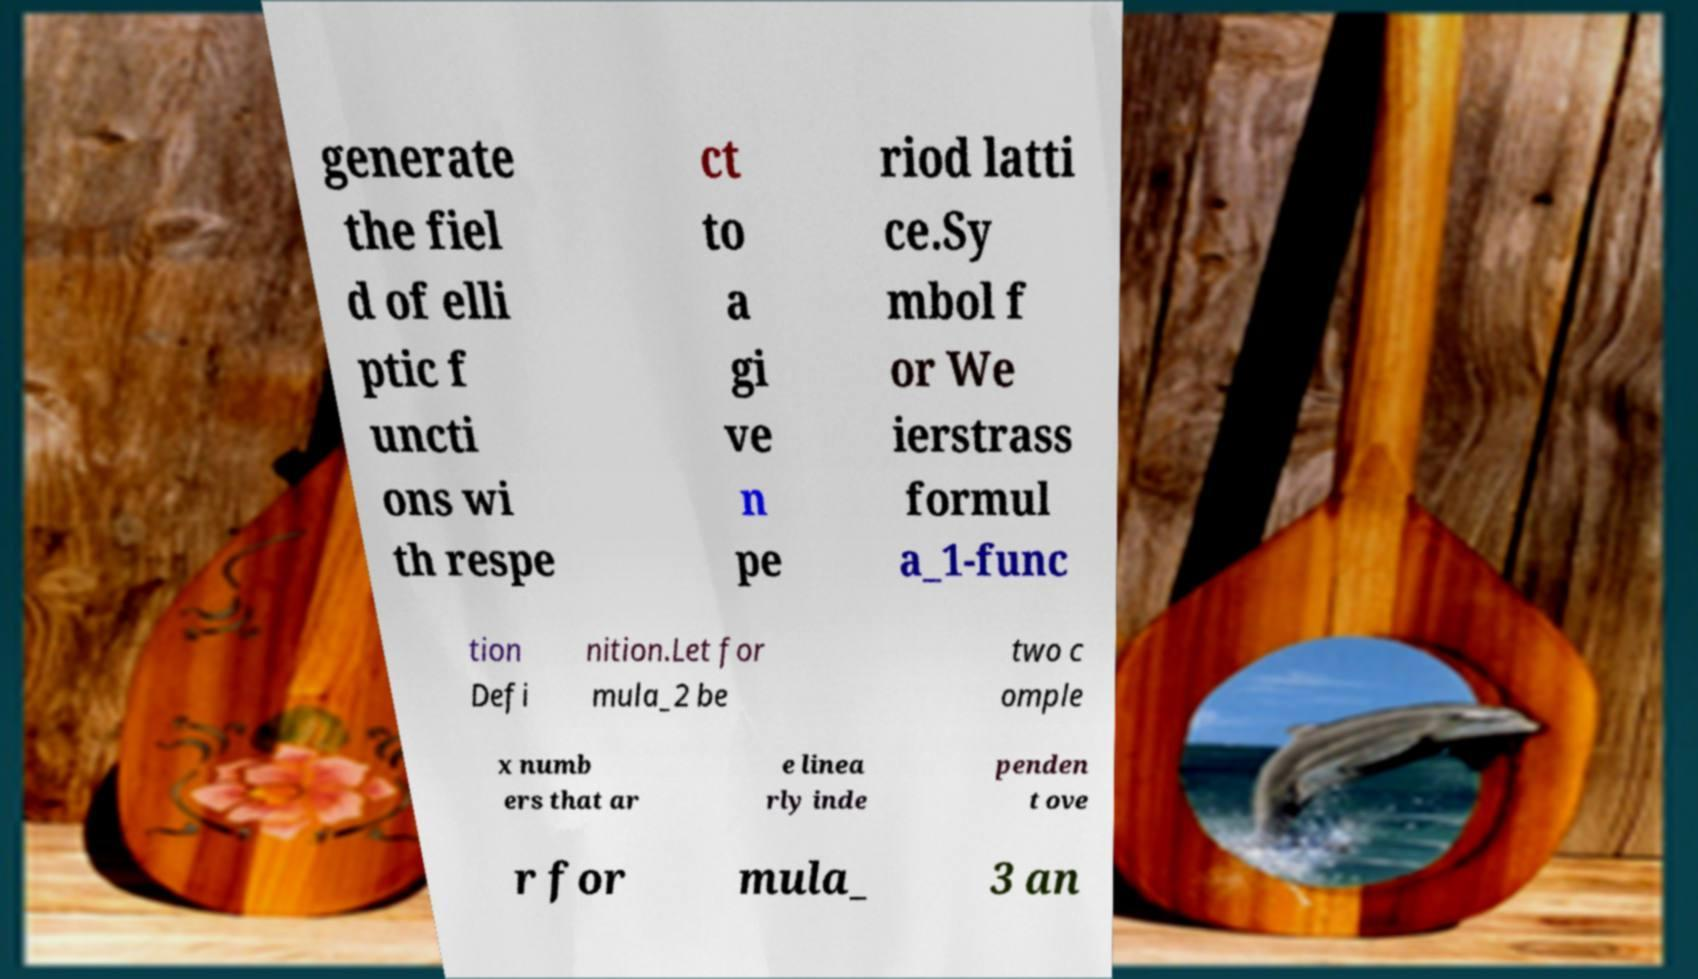For documentation purposes, I need the text within this image transcribed. Could you provide that? generate the fiel d of elli ptic f uncti ons wi th respe ct to a gi ve n pe riod latti ce.Sy mbol f or We ierstrass formul a_1-func tion Defi nition.Let for mula_2 be two c omple x numb ers that ar e linea rly inde penden t ove r for mula_ 3 an 